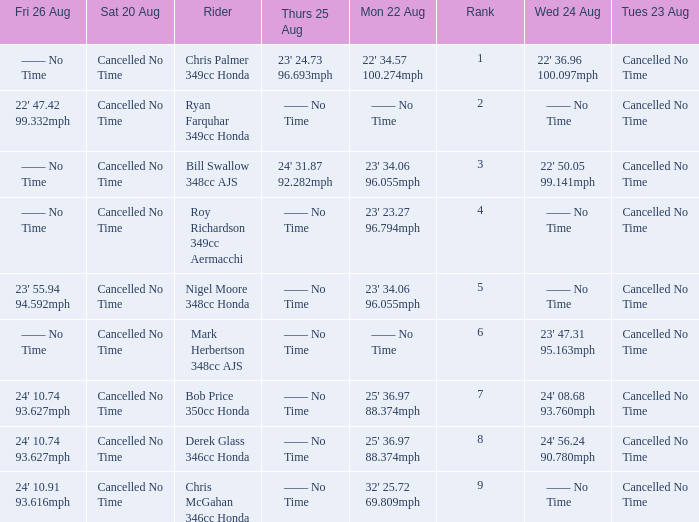What is every entry for Friday August 26 if the entry for Monday August 22 is 32' 25.72 69.809mph? 24' 10.91 93.616mph. 